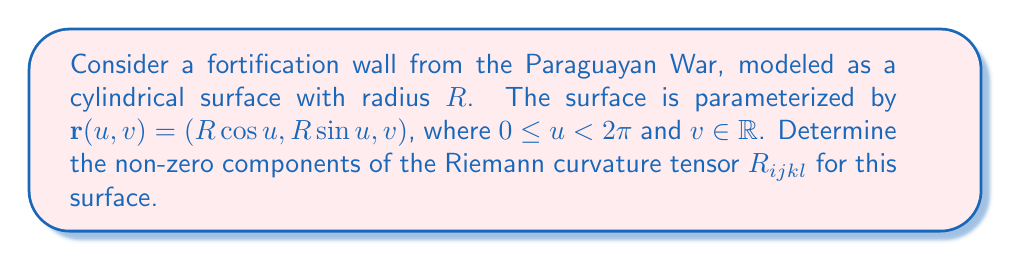What is the answer to this math problem? To find the curvature tensor, we'll follow these steps:

1) First, calculate the metric tensor $g_{ij}$:
   $$\mathbf{r}_u = (-R\sin u, R\cos u, 0)$$
   $$\mathbf{r}_v = (0, 0, 1)$$
   $$g_{11} = R^2, g_{12} = g_{21} = 0, g_{22} = 1$$

2) The inverse metric tensor $g^{ij}$ is:
   $$g^{11} = \frac{1}{R^2}, g^{12} = g^{21} = 0, g^{22} = 1$$

3) Calculate the Christoffel symbols:
   $$\Gamma^i_{jk} = \frac{1}{2}g^{im}(\partial_j g_{km} + \partial_k g_{jm} - \partial_m g_{jk})$$
   The only non-zero Christoffel symbol is:
   $$\Gamma^2_{11} = -R$$

4) Now, we can calculate the Riemann curvature tensor:
   $$R^i_{jkl} = \partial_k \Gamma^i_{jl} - \partial_l \Gamma^i_{jk} + \Gamma^m_{jl}\Gamma^i_{km} - \Gamma^m_{jk}\Gamma^i_{lm}$$

   The only non-zero component is:
   $$R^1_{212} = -R^1_{221} = \partial_1 \Gamma^1_{22} - \partial_2 \Gamma^1_{21} + \Gamma^m_{22}\Gamma^1_{1m} - \Gamma^m_{21}\Gamma^1_{2m} = -1$$

5) Lower the first index to get $R_{ijkl}$:
   $$R_{1212} = g_{1m}R^m_{212} = R^2 \cdot (-1) = -R^2$$

Therefore, the non-zero components of the Riemann curvature tensor are:
$$R_{1212} = -R_{1221} = -R_{2112} = R_{2121} = -R^2$$
Answer: $R_{1212} = -R_{1221} = -R_{2112} = R_{2121} = -R^2$ 